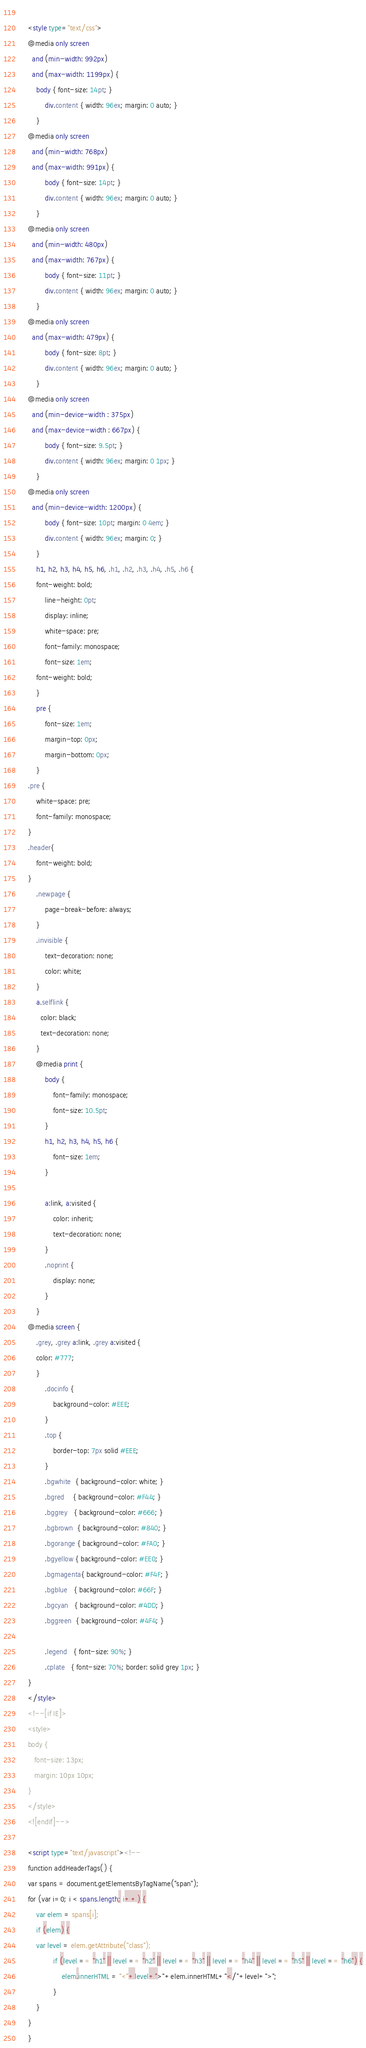<code> <loc_0><loc_0><loc_500><loc_500><_HTML_>    
    <style type="text/css">
	@media only screen 
	  and (min-width: 992px)
	  and (max-width: 1199px) {
	    body { font-size: 14pt; }
            div.content { width: 96ex; margin: 0 auto; }
        }
	@media only screen 
	  and (min-width: 768px)
	  and (max-width: 991px) {
            body { font-size: 14pt; }
            div.content { width: 96ex; margin: 0 auto; }
        }
	@media only screen 
	  and (min-width: 480px)
	  and (max-width: 767px) {
            body { font-size: 11pt; }
            div.content { width: 96ex; margin: 0 auto; }
        }
	@media only screen 
	  and (max-width: 479px) {
            body { font-size: 8pt; }
            div.content { width: 96ex; margin: 0 auto; }
        }
	@media only screen 
	  and (min-device-width : 375px) 
	  and (max-device-width : 667px) {
            body { font-size: 9.5pt; }
            div.content { width: 96ex; margin: 0 1px; }
        }
	@media only screen 
	  and (min-device-width: 1200px) {
            body { font-size: 10pt; margin: 0 4em; }
            div.content { width: 96ex; margin: 0; }
        }
        h1, h2, h3, h4, h5, h6, .h1, .h2, .h3, .h4, .h5, .h6 {
	    font-weight: bold;
            line-height: 0pt;
            display: inline;
            white-space: pre;
            font-family: monospace;
            font-size: 1em;
	    font-weight: bold;
        }
        pre {
            font-size: 1em;
            margin-top: 0px;
            margin-bottom: 0px;
        }
	.pre {
	    white-space: pre;
	    font-family: monospace;
	}
	.header{
	    font-weight: bold;
	}
        .newpage {
            page-break-before: always;
        }
        .invisible {
            text-decoration: none;
            color: white;
        }
        a.selflink {
          color: black;
          text-decoration: none;
        }
        @media print {
            body {
                font-family: monospace;
                font-size: 10.5pt;
            }
            h1, h2, h3, h4, h5, h6 {
                font-size: 1em;
            }
        
            a:link, a:visited {
                color: inherit;
                text-decoration: none;
            }
            .noprint {
                display: none;
            }
        }
	@media screen {
	    .grey, .grey a:link, .grey a:visited {
		color: #777;
	    }
            .docinfo {
                background-color: #EEE;
            }
            .top {
                border-top: 7px solid #EEE;
            }
            .bgwhite  { background-color: white; }
            .bgred    { background-color: #F44; }
            .bggrey   { background-color: #666; }
            .bgbrown  { background-color: #840; }            
            .bgorange { background-color: #FA0; }
            .bgyellow { background-color: #EE0; }
            .bgmagenta{ background-color: #F4F; }
            .bgblue   { background-color: #66F; }
            .bgcyan   { background-color: #4DD; }
            .bggreen  { background-color: #4F4; }

            .legend   { font-size: 90%; }
            .cplate   { font-size: 70%; border: solid grey 1px; }
	}
    </style>
    <!--[if IE]>
    <style>
    body {
       font-size: 13px;
       margin: 10px 10px;
    }
    </style>
    <![endif]-->

    <script type="text/javascript"><!--
    function addHeaderTags() {
	var spans = document.getElementsByTagName("span");
	for (var i=0; i < spans.length; i++) {
	    var elem = spans[i];
	    if (elem) {
		var level = elem.getAttribute("class");
                if (level == "h1" || level == "h2" || level == "h3" || level == "h4" || level == "h5" || level == "h6") {
                    elem.innerHTML = "<"+level+">"+elem.innerHTML+"</"+level+">";		
                }
	    }
	}
    }</code> 